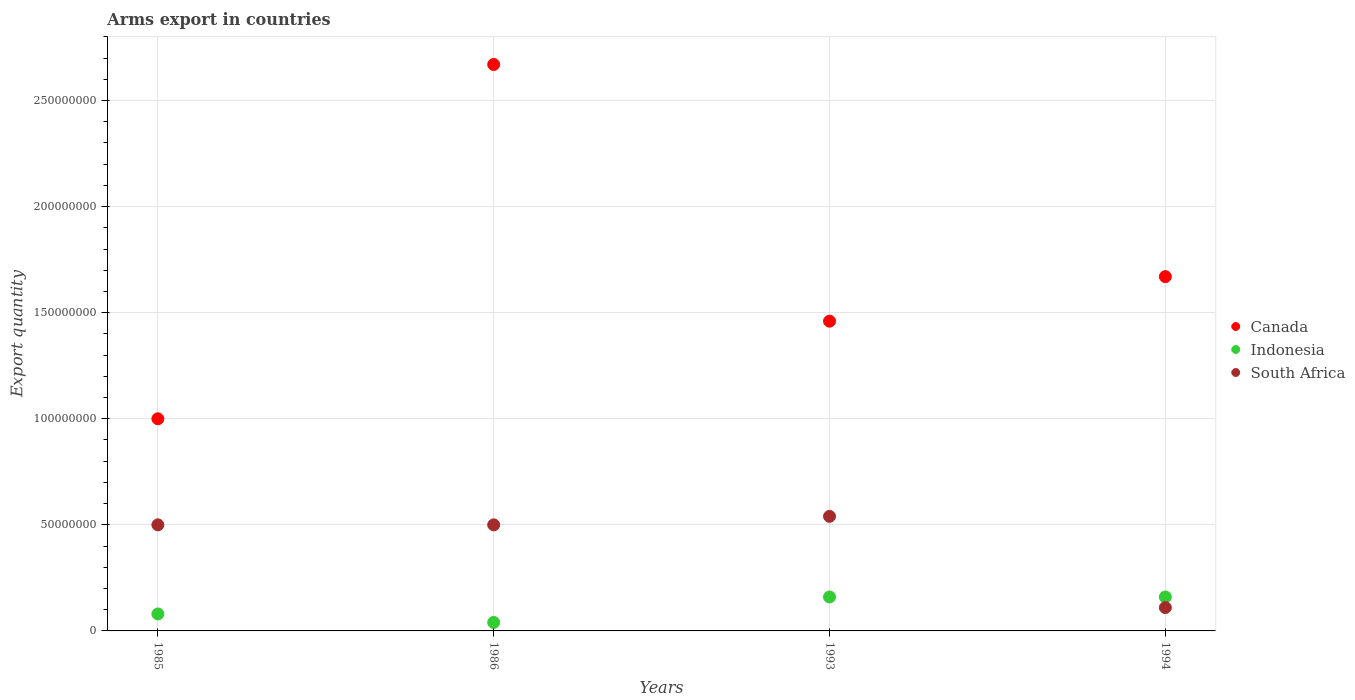How many different coloured dotlines are there?
Your answer should be very brief. 3. What is the total arms export in Indonesia in 1985?
Provide a succinct answer. 8.00e+06. Across all years, what is the maximum total arms export in South Africa?
Offer a terse response. 5.40e+07. Across all years, what is the minimum total arms export in Indonesia?
Keep it short and to the point. 4.00e+06. In which year was the total arms export in Indonesia maximum?
Your answer should be very brief. 1993. What is the total total arms export in Canada in the graph?
Offer a very short reply. 6.80e+08. What is the difference between the total arms export in South Africa in 1985 and that in 1994?
Ensure brevity in your answer.  3.90e+07. What is the difference between the total arms export in Canada in 1985 and the total arms export in South Africa in 1993?
Make the answer very short. 4.60e+07. What is the average total arms export in Canada per year?
Offer a terse response. 1.70e+08. In the year 1986, what is the difference between the total arms export in Canada and total arms export in Indonesia?
Offer a very short reply. 2.63e+08. What is the ratio of the total arms export in Canada in 1986 to that in 1994?
Ensure brevity in your answer.  1.6. Is the difference between the total arms export in Canada in 1985 and 1986 greater than the difference between the total arms export in Indonesia in 1985 and 1986?
Ensure brevity in your answer.  No. What is the difference between the highest and the lowest total arms export in South Africa?
Offer a terse response. 4.30e+07. Is the sum of the total arms export in Indonesia in 1985 and 1994 greater than the maximum total arms export in Canada across all years?
Provide a succinct answer. No. Does the total arms export in Canada monotonically increase over the years?
Ensure brevity in your answer.  No. Is the total arms export in South Africa strictly greater than the total arms export in Indonesia over the years?
Your answer should be very brief. No. Is the total arms export in South Africa strictly less than the total arms export in Canada over the years?
Provide a succinct answer. Yes. What is the difference between two consecutive major ticks on the Y-axis?
Ensure brevity in your answer.  5.00e+07. Does the graph contain grids?
Provide a short and direct response. Yes. How are the legend labels stacked?
Your answer should be very brief. Vertical. What is the title of the graph?
Provide a succinct answer. Arms export in countries. What is the label or title of the Y-axis?
Your answer should be compact. Export quantity. What is the Export quantity of Canada in 1985?
Give a very brief answer. 1.00e+08. What is the Export quantity in Indonesia in 1985?
Keep it short and to the point. 8.00e+06. What is the Export quantity of Canada in 1986?
Give a very brief answer. 2.67e+08. What is the Export quantity of South Africa in 1986?
Provide a short and direct response. 5.00e+07. What is the Export quantity of Canada in 1993?
Ensure brevity in your answer.  1.46e+08. What is the Export quantity in Indonesia in 1993?
Provide a succinct answer. 1.60e+07. What is the Export quantity of South Africa in 1993?
Provide a succinct answer. 5.40e+07. What is the Export quantity of Canada in 1994?
Keep it short and to the point. 1.67e+08. What is the Export quantity of Indonesia in 1994?
Your answer should be compact. 1.60e+07. What is the Export quantity in South Africa in 1994?
Keep it short and to the point. 1.10e+07. Across all years, what is the maximum Export quantity in Canada?
Your answer should be very brief. 2.67e+08. Across all years, what is the maximum Export quantity in Indonesia?
Provide a succinct answer. 1.60e+07. Across all years, what is the maximum Export quantity in South Africa?
Your response must be concise. 5.40e+07. Across all years, what is the minimum Export quantity of Canada?
Give a very brief answer. 1.00e+08. Across all years, what is the minimum Export quantity in Indonesia?
Provide a succinct answer. 4.00e+06. Across all years, what is the minimum Export quantity of South Africa?
Provide a succinct answer. 1.10e+07. What is the total Export quantity in Canada in the graph?
Your answer should be compact. 6.80e+08. What is the total Export quantity in Indonesia in the graph?
Make the answer very short. 4.40e+07. What is the total Export quantity in South Africa in the graph?
Offer a very short reply. 1.65e+08. What is the difference between the Export quantity of Canada in 1985 and that in 1986?
Your answer should be compact. -1.67e+08. What is the difference between the Export quantity in Canada in 1985 and that in 1993?
Give a very brief answer. -4.60e+07. What is the difference between the Export quantity of Indonesia in 1985 and that in 1993?
Keep it short and to the point. -8.00e+06. What is the difference between the Export quantity of Canada in 1985 and that in 1994?
Provide a succinct answer. -6.70e+07. What is the difference between the Export quantity in Indonesia in 1985 and that in 1994?
Your response must be concise. -8.00e+06. What is the difference between the Export quantity of South Africa in 1985 and that in 1994?
Provide a short and direct response. 3.90e+07. What is the difference between the Export quantity of Canada in 1986 and that in 1993?
Provide a short and direct response. 1.21e+08. What is the difference between the Export quantity in Indonesia in 1986 and that in 1993?
Provide a short and direct response. -1.20e+07. What is the difference between the Export quantity of Canada in 1986 and that in 1994?
Ensure brevity in your answer.  1.00e+08. What is the difference between the Export quantity of Indonesia in 1986 and that in 1994?
Offer a very short reply. -1.20e+07. What is the difference between the Export quantity of South Africa in 1986 and that in 1994?
Your answer should be compact. 3.90e+07. What is the difference between the Export quantity of Canada in 1993 and that in 1994?
Your answer should be compact. -2.10e+07. What is the difference between the Export quantity of South Africa in 1993 and that in 1994?
Your answer should be very brief. 4.30e+07. What is the difference between the Export quantity in Canada in 1985 and the Export quantity in Indonesia in 1986?
Make the answer very short. 9.60e+07. What is the difference between the Export quantity in Canada in 1985 and the Export quantity in South Africa in 1986?
Make the answer very short. 5.00e+07. What is the difference between the Export quantity in Indonesia in 1985 and the Export quantity in South Africa in 1986?
Give a very brief answer. -4.20e+07. What is the difference between the Export quantity in Canada in 1985 and the Export quantity in Indonesia in 1993?
Offer a terse response. 8.40e+07. What is the difference between the Export quantity in Canada in 1985 and the Export quantity in South Africa in 1993?
Offer a very short reply. 4.60e+07. What is the difference between the Export quantity in Indonesia in 1985 and the Export quantity in South Africa in 1993?
Offer a very short reply. -4.60e+07. What is the difference between the Export quantity in Canada in 1985 and the Export quantity in Indonesia in 1994?
Make the answer very short. 8.40e+07. What is the difference between the Export quantity in Canada in 1985 and the Export quantity in South Africa in 1994?
Ensure brevity in your answer.  8.90e+07. What is the difference between the Export quantity in Canada in 1986 and the Export quantity in Indonesia in 1993?
Your answer should be compact. 2.51e+08. What is the difference between the Export quantity in Canada in 1986 and the Export quantity in South Africa in 1993?
Provide a short and direct response. 2.13e+08. What is the difference between the Export quantity in Indonesia in 1986 and the Export quantity in South Africa in 1993?
Give a very brief answer. -5.00e+07. What is the difference between the Export quantity of Canada in 1986 and the Export quantity of Indonesia in 1994?
Your answer should be compact. 2.51e+08. What is the difference between the Export quantity in Canada in 1986 and the Export quantity in South Africa in 1994?
Your answer should be compact. 2.56e+08. What is the difference between the Export quantity in Indonesia in 1986 and the Export quantity in South Africa in 1994?
Keep it short and to the point. -7.00e+06. What is the difference between the Export quantity in Canada in 1993 and the Export quantity in Indonesia in 1994?
Offer a terse response. 1.30e+08. What is the difference between the Export quantity of Canada in 1993 and the Export quantity of South Africa in 1994?
Offer a terse response. 1.35e+08. What is the average Export quantity in Canada per year?
Give a very brief answer. 1.70e+08. What is the average Export quantity in Indonesia per year?
Your response must be concise. 1.10e+07. What is the average Export quantity in South Africa per year?
Provide a succinct answer. 4.12e+07. In the year 1985, what is the difference between the Export quantity of Canada and Export quantity of Indonesia?
Give a very brief answer. 9.20e+07. In the year 1985, what is the difference between the Export quantity of Indonesia and Export quantity of South Africa?
Give a very brief answer. -4.20e+07. In the year 1986, what is the difference between the Export quantity of Canada and Export quantity of Indonesia?
Make the answer very short. 2.63e+08. In the year 1986, what is the difference between the Export quantity of Canada and Export quantity of South Africa?
Offer a terse response. 2.17e+08. In the year 1986, what is the difference between the Export quantity in Indonesia and Export quantity in South Africa?
Your response must be concise. -4.60e+07. In the year 1993, what is the difference between the Export quantity of Canada and Export quantity of Indonesia?
Your answer should be compact. 1.30e+08. In the year 1993, what is the difference between the Export quantity of Canada and Export quantity of South Africa?
Your answer should be very brief. 9.20e+07. In the year 1993, what is the difference between the Export quantity of Indonesia and Export quantity of South Africa?
Offer a very short reply. -3.80e+07. In the year 1994, what is the difference between the Export quantity of Canada and Export quantity of Indonesia?
Ensure brevity in your answer.  1.51e+08. In the year 1994, what is the difference between the Export quantity in Canada and Export quantity in South Africa?
Offer a very short reply. 1.56e+08. In the year 1994, what is the difference between the Export quantity of Indonesia and Export quantity of South Africa?
Your answer should be very brief. 5.00e+06. What is the ratio of the Export quantity of Canada in 1985 to that in 1986?
Provide a succinct answer. 0.37. What is the ratio of the Export quantity of Indonesia in 1985 to that in 1986?
Give a very brief answer. 2. What is the ratio of the Export quantity of Canada in 1985 to that in 1993?
Make the answer very short. 0.68. What is the ratio of the Export quantity of Indonesia in 1985 to that in 1993?
Keep it short and to the point. 0.5. What is the ratio of the Export quantity of South Africa in 1985 to that in 1993?
Provide a short and direct response. 0.93. What is the ratio of the Export quantity of Canada in 1985 to that in 1994?
Your response must be concise. 0.6. What is the ratio of the Export quantity of Indonesia in 1985 to that in 1994?
Offer a terse response. 0.5. What is the ratio of the Export quantity of South Africa in 1985 to that in 1994?
Your response must be concise. 4.55. What is the ratio of the Export quantity of Canada in 1986 to that in 1993?
Offer a terse response. 1.83. What is the ratio of the Export quantity in Indonesia in 1986 to that in 1993?
Provide a succinct answer. 0.25. What is the ratio of the Export quantity of South Africa in 1986 to that in 1993?
Ensure brevity in your answer.  0.93. What is the ratio of the Export quantity of Canada in 1986 to that in 1994?
Your answer should be very brief. 1.6. What is the ratio of the Export quantity of South Africa in 1986 to that in 1994?
Provide a short and direct response. 4.55. What is the ratio of the Export quantity of Canada in 1993 to that in 1994?
Your answer should be compact. 0.87. What is the ratio of the Export quantity in Indonesia in 1993 to that in 1994?
Provide a succinct answer. 1. What is the ratio of the Export quantity of South Africa in 1993 to that in 1994?
Offer a terse response. 4.91. What is the difference between the highest and the second highest Export quantity of Canada?
Offer a very short reply. 1.00e+08. What is the difference between the highest and the lowest Export quantity of Canada?
Give a very brief answer. 1.67e+08. What is the difference between the highest and the lowest Export quantity in Indonesia?
Offer a terse response. 1.20e+07. What is the difference between the highest and the lowest Export quantity of South Africa?
Offer a terse response. 4.30e+07. 